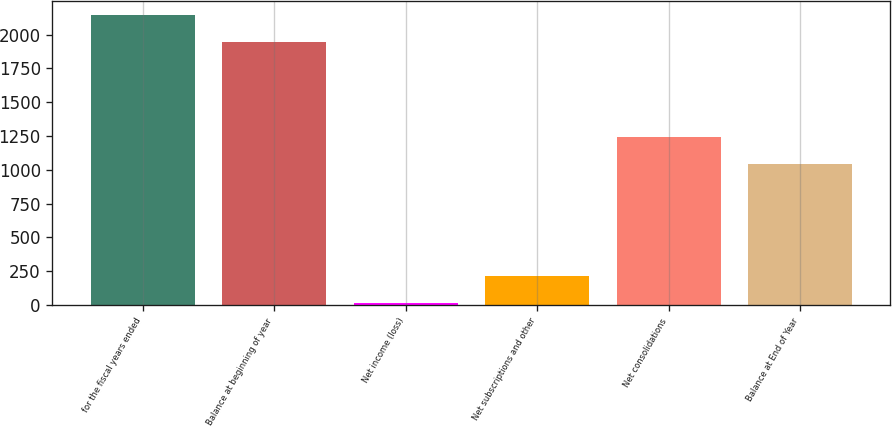Convert chart. <chart><loc_0><loc_0><loc_500><loc_500><bar_chart><fcel>for the fiscal years ended<fcel>Balance at beginning of year<fcel>Net income (loss)<fcel>Net subscriptions and other<fcel>Net consolidations<fcel>Balance at End of Year<nl><fcel>2142.42<fcel>1941.9<fcel>12.8<fcel>213.32<fcel>1244.12<fcel>1043.6<nl></chart> 